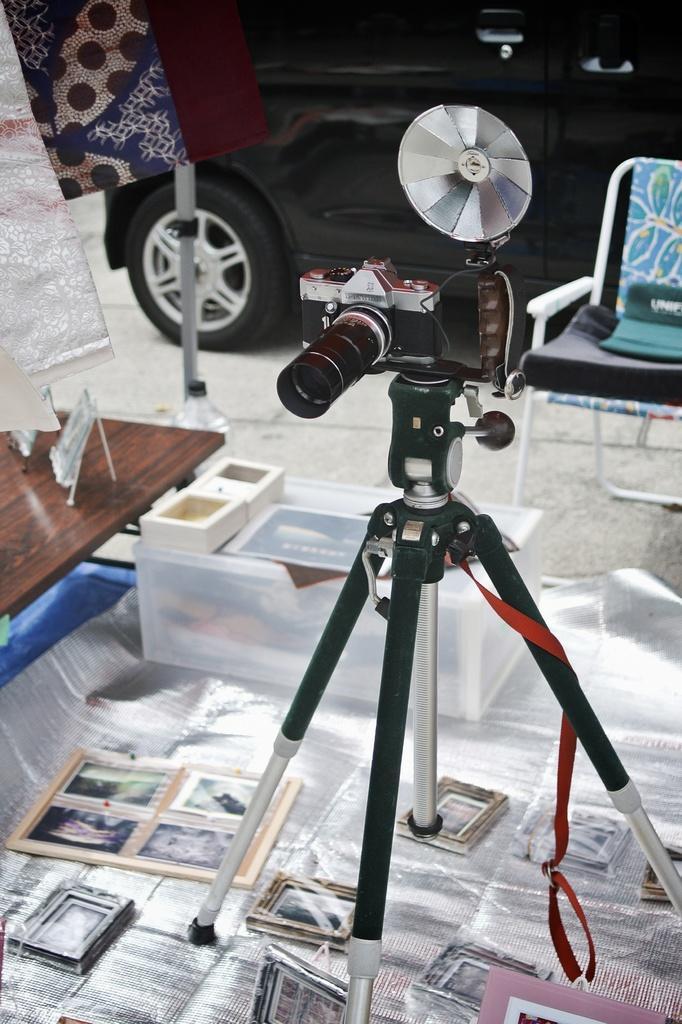Describe this image in one or two sentences. In this image I can see a camera, camera stand, pictures, container, table, vehicle, chair and objects.   